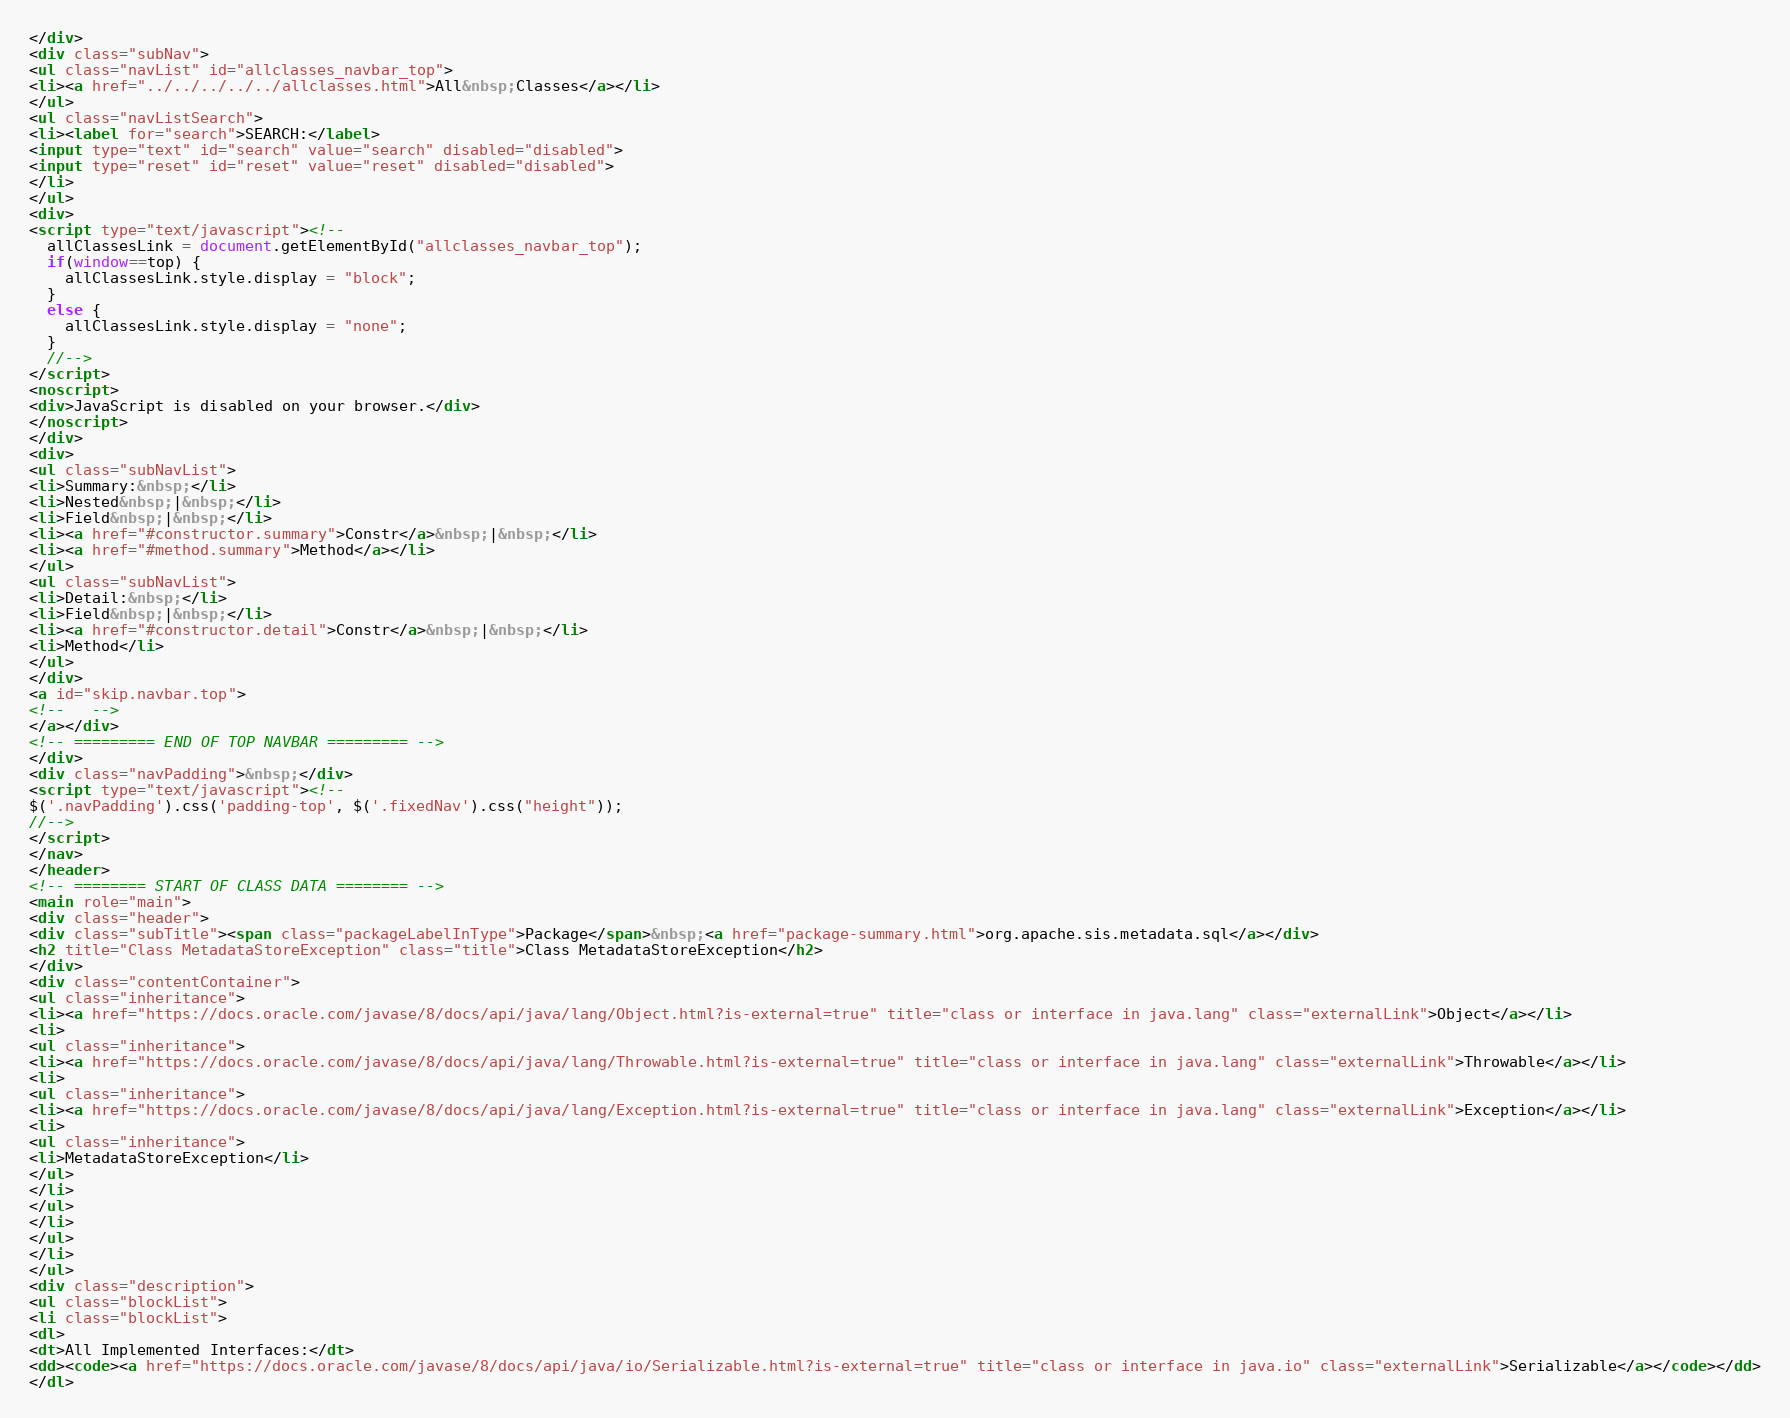Convert code to text. <code><loc_0><loc_0><loc_500><loc_500><_HTML_></div>
<div class="subNav">
<ul class="navList" id="allclasses_navbar_top">
<li><a href="../../../../../allclasses.html">All&nbsp;Classes</a></li>
</ul>
<ul class="navListSearch">
<li><label for="search">SEARCH:</label>
<input type="text" id="search" value="search" disabled="disabled">
<input type="reset" id="reset" value="reset" disabled="disabled">
</li>
</ul>
<div>
<script type="text/javascript"><!--
  allClassesLink = document.getElementById("allclasses_navbar_top");
  if(window==top) {
    allClassesLink.style.display = "block";
  }
  else {
    allClassesLink.style.display = "none";
  }
  //-->
</script>
<noscript>
<div>JavaScript is disabled on your browser.</div>
</noscript>
</div>
<div>
<ul class="subNavList">
<li>Summary:&nbsp;</li>
<li>Nested&nbsp;|&nbsp;</li>
<li>Field&nbsp;|&nbsp;</li>
<li><a href="#constructor.summary">Constr</a>&nbsp;|&nbsp;</li>
<li><a href="#method.summary">Method</a></li>
</ul>
<ul class="subNavList">
<li>Detail:&nbsp;</li>
<li>Field&nbsp;|&nbsp;</li>
<li><a href="#constructor.detail">Constr</a>&nbsp;|&nbsp;</li>
<li>Method</li>
</ul>
</div>
<a id="skip.navbar.top">
<!--   -->
</a></div>
<!-- ========= END OF TOP NAVBAR ========= -->
</div>
<div class="navPadding">&nbsp;</div>
<script type="text/javascript"><!--
$('.navPadding').css('padding-top', $('.fixedNav').css("height"));
//-->
</script>
</nav>
</header>
<!-- ======== START OF CLASS DATA ======== -->
<main role="main">
<div class="header">
<div class="subTitle"><span class="packageLabelInType">Package</span>&nbsp;<a href="package-summary.html">org.apache.sis.metadata.sql</a></div>
<h2 title="Class MetadataStoreException" class="title">Class MetadataStoreException</h2>
</div>
<div class="contentContainer">
<ul class="inheritance">
<li><a href="https://docs.oracle.com/javase/8/docs/api/java/lang/Object.html?is-external=true" title="class or interface in java.lang" class="externalLink">Object</a></li>
<li>
<ul class="inheritance">
<li><a href="https://docs.oracle.com/javase/8/docs/api/java/lang/Throwable.html?is-external=true" title="class or interface in java.lang" class="externalLink">Throwable</a></li>
<li>
<ul class="inheritance">
<li><a href="https://docs.oracle.com/javase/8/docs/api/java/lang/Exception.html?is-external=true" title="class or interface in java.lang" class="externalLink">Exception</a></li>
<li>
<ul class="inheritance">
<li>MetadataStoreException</li>
</ul>
</li>
</ul>
</li>
</ul>
</li>
</ul>
<div class="description">
<ul class="blockList">
<li class="blockList">
<dl>
<dt>All Implemented Interfaces:</dt>
<dd><code><a href="https://docs.oracle.com/javase/8/docs/api/java/io/Serializable.html?is-external=true" title="class or interface in java.io" class="externalLink">Serializable</a></code></dd>
</dl></code> 